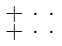Convert formula to latex. <formula><loc_0><loc_0><loc_500><loc_500>\begin{smallmatrix} + & \cdot & \cdot \\ + & \cdot & \cdot \end{smallmatrix}</formula> 